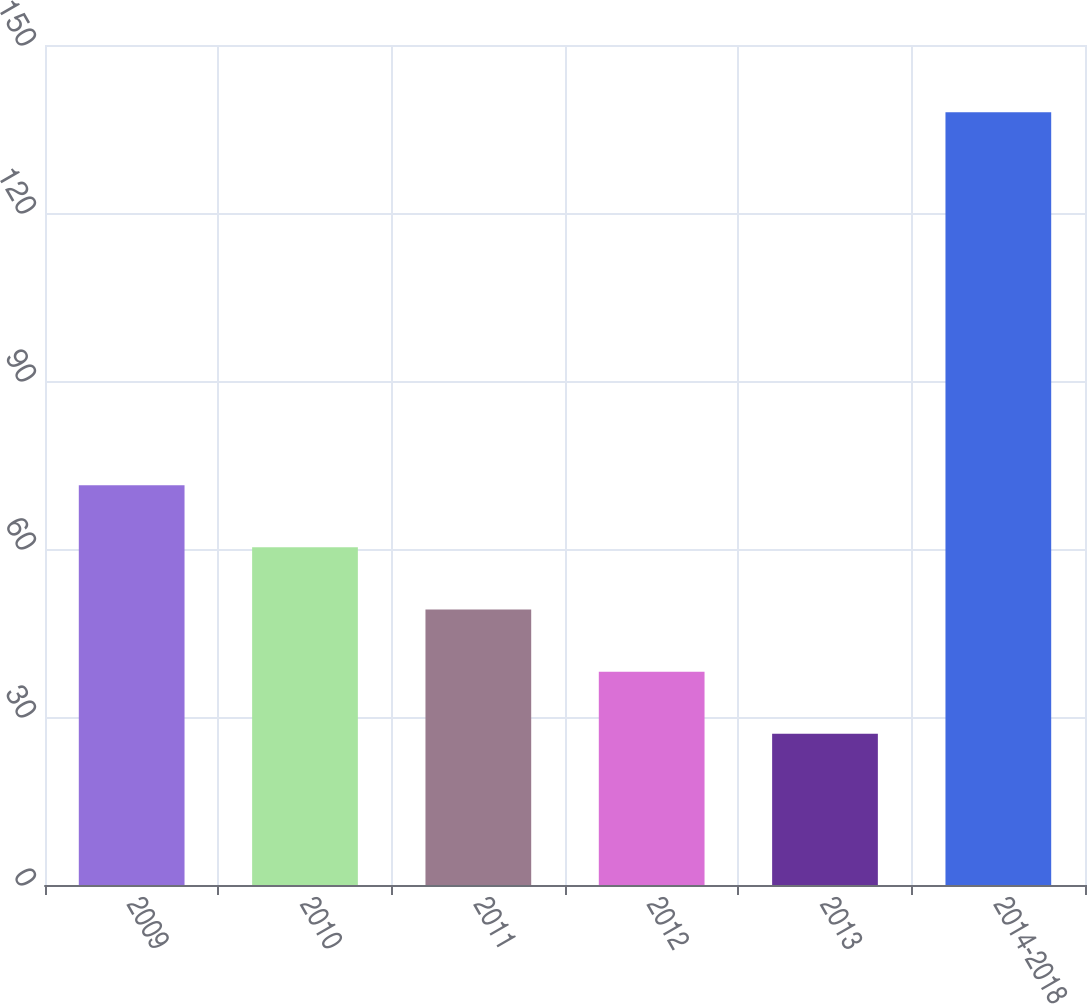Convert chart. <chart><loc_0><loc_0><loc_500><loc_500><bar_chart><fcel>2009<fcel>2010<fcel>2011<fcel>2012<fcel>2013<fcel>2014-2018<nl><fcel>71.4<fcel>60.3<fcel>49.2<fcel>38.1<fcel>27<fcel>138<nl></chart> 